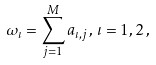<formula> <loc_0><loc_0><loc_500><loc_500>\omega _ { \iota } = \sum ^ { M } _ { j = 1 } a _ { \iota , j } \, , \, \iota = 1 , 2 \, ,</formula> 